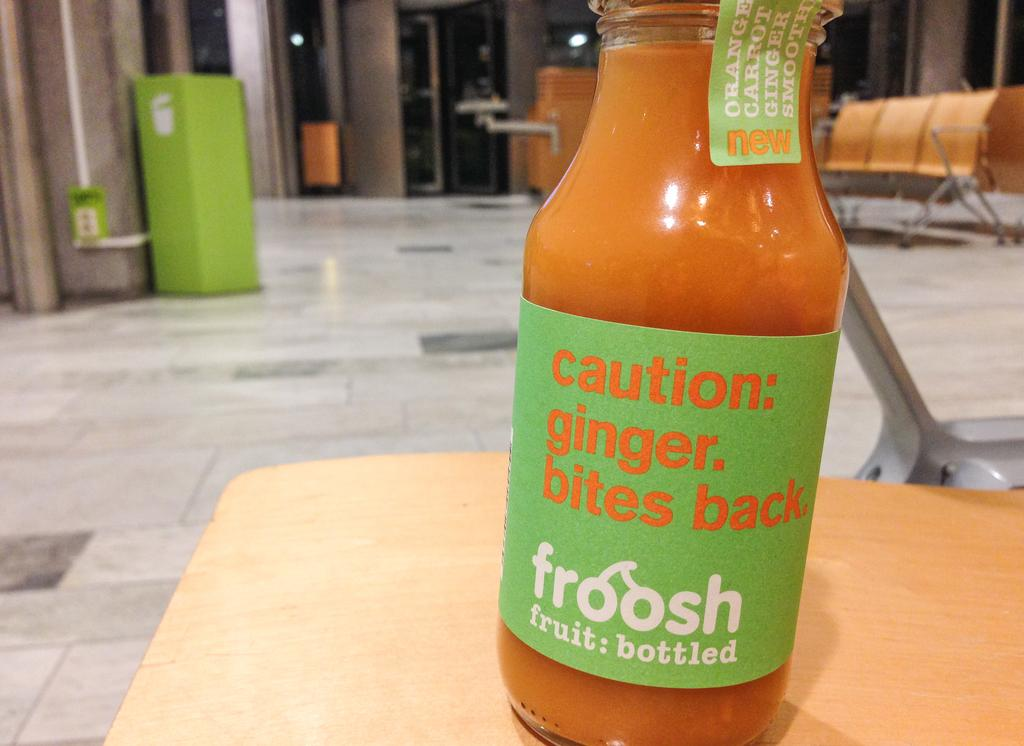<image>
Offer a succinct explanation of the picture presented. A bottle of Froosh says caution: ginger, bites back 